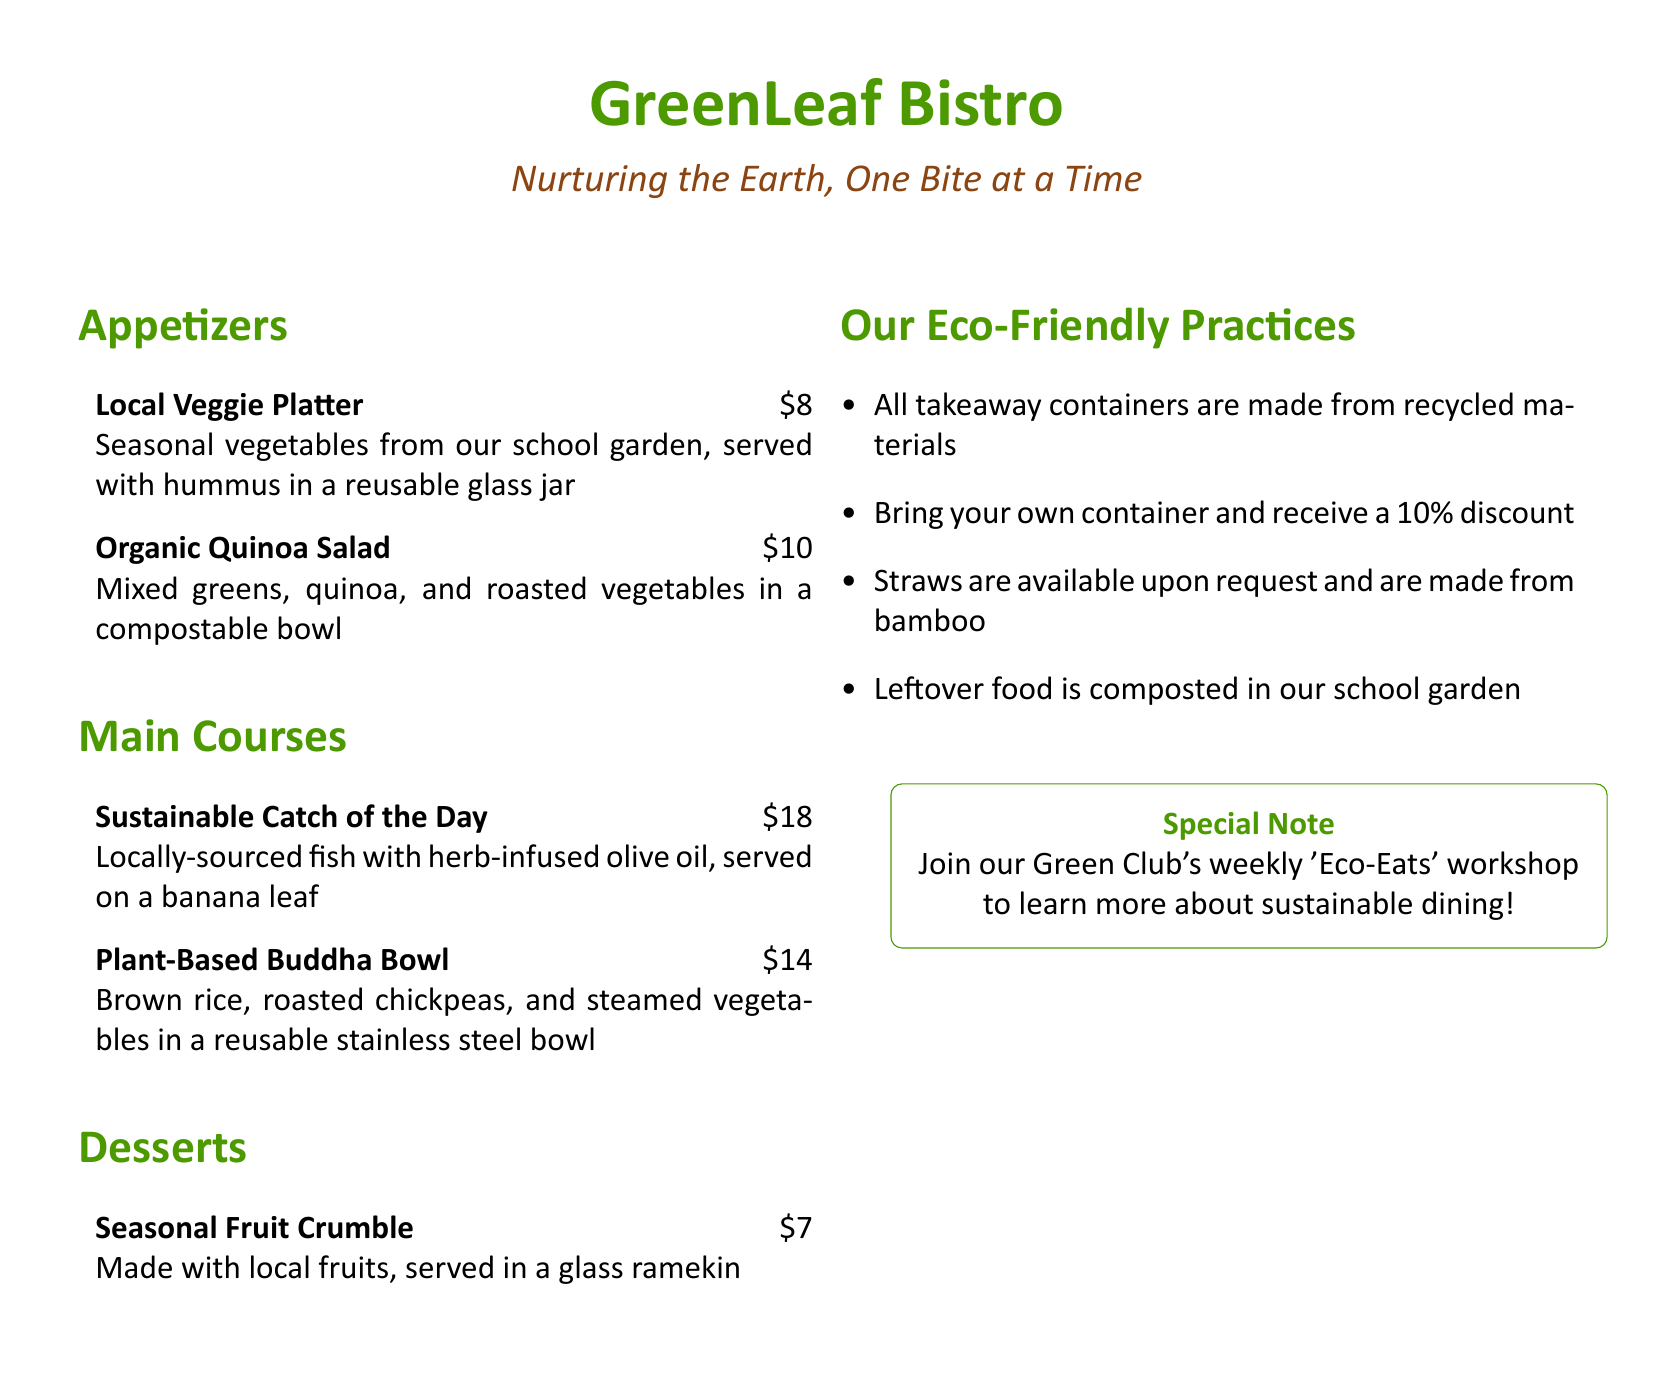what is the name of the bistro? The name of the bistro is presented prominently at the top of the menu.
Answer: GreenLeaf Bistro how much does the Local Veggie Platter cost? The cost of the Local Veggie Platter is listed next to the item on the menu.
Answer: $8 what type of container is used for the Organic Quinoa Salad? The type of container used for the Organic Quinoa Salad is specified in the description.
Answer: compostable bowl what percentage discount do you receive for bringing your own container? The discount percentage for bringing your own container is explicitly mentioned.
Answer: 10% what is made available upon request? The item that is made available upon request is listed in the eco-friendly practices section.
Answer: straws which dish is served on a banana leaf? The dish served on a banana leaf is noted in the description of the main courses.
Answer: Sustainable Catch of the Day what is composted in the school garden? The eco-friendly practice describing what is composted is clearly pointed out in the practices section.
Answer: leftover food what is the price of the Plant-Based Buddha Bowl? The price of the Plant-Based Buddha Bowl is stated next to the item on the menu.
Answer: $14 who can join the weekly 'Eco-Eats' workshop? The group inviting to join the workshop is specified in the special note section of the menu.
Answer: Green Club 